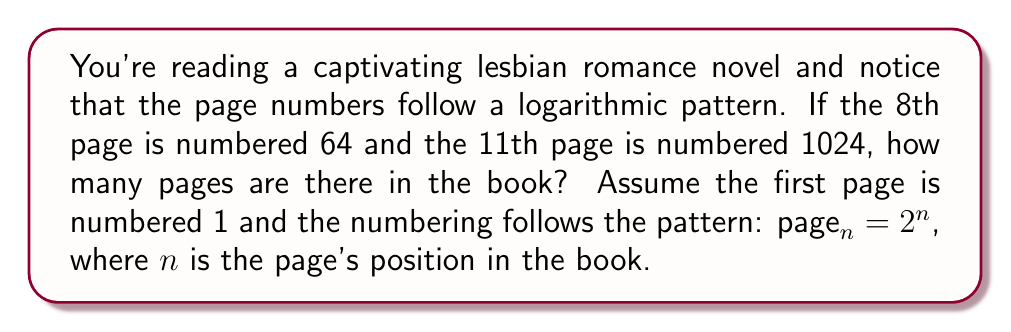What is the answer to this math problem? Let's approach this step-by-step:

1) We're given that the page numbering follows the pattern $page_n = 2^n$

2) For the 8th page: $64 = 2^n$
   For the 11th page: $1024 = 2^n$

3) We can verify this:
   For 8th page: $2^6 = 64$
   For 11th page: $2^{10} = 1024$

4) To find the total number of pages, we need to find the largest value of $n$ where $2^n$ is still a valid page number.

5) Let's call the total number of pages $x$. Then:

   $2^x \leq $ total pages in the book $< 2^{x+1}$

6) Taking $\log_2$ of both sides:

   $\log_2(2^x) \leq \log_2($total pages$) < \log_2(2^{x+1})$

7) Simplifying:

   $x \leq \log_2($total pages$) < x+1$

8) This means that $x$ is the floor of $\log_2($total pages$)$

9) The largest possible page number is one less than the total number of pages.

10) So, we need to solve:

    $\log_2($largest page number$) = x$

11) The largest page number that fits the pattern is $2^{13} = 8192$

12) Therefore, the book has $8192 + 1 = 8193$ pages.
Answer: 8193 pages 